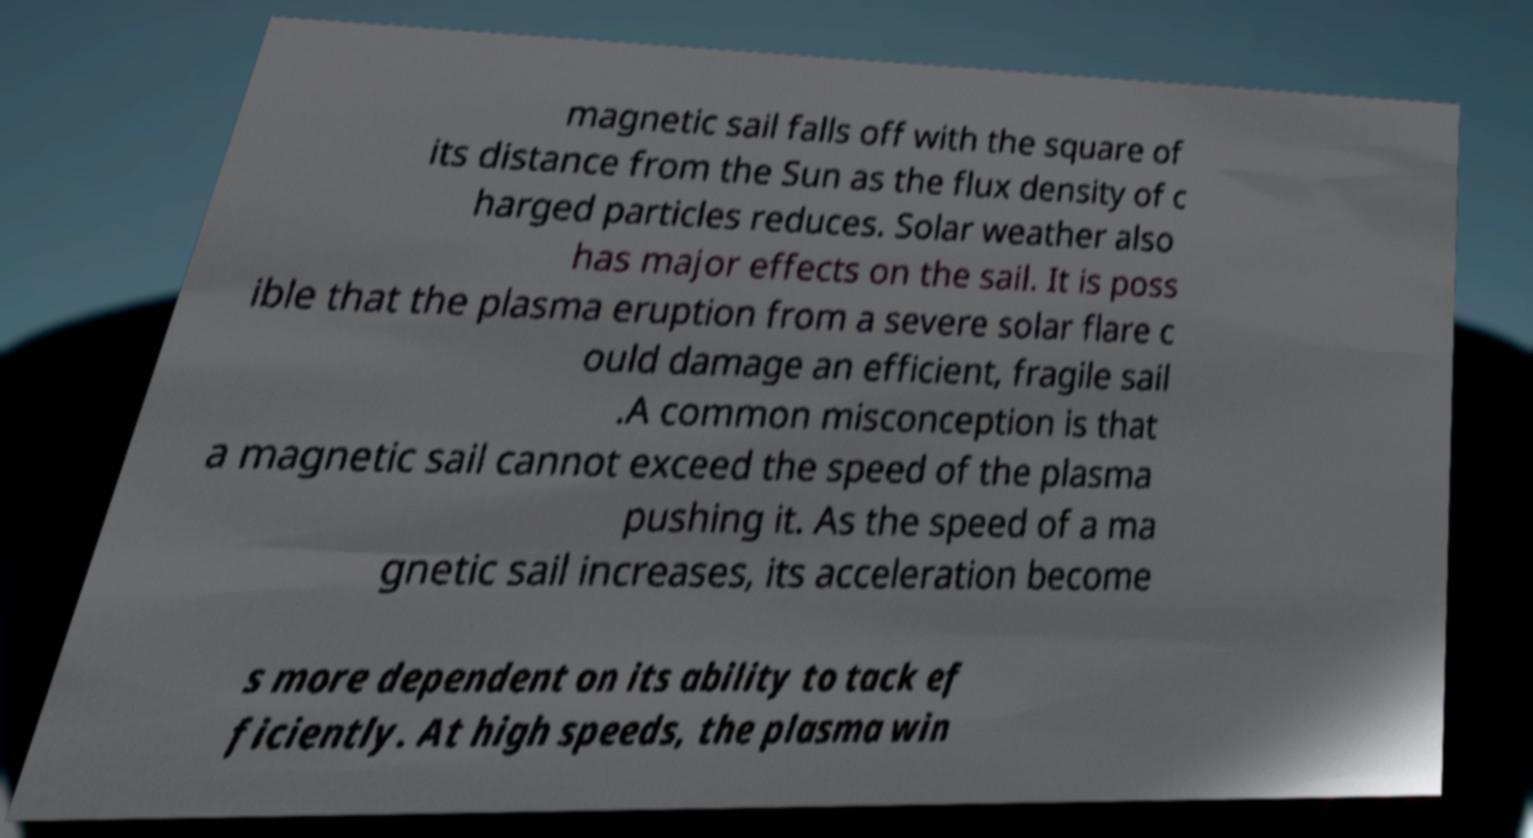Can you accurately transcribe the text from the provided image for me? magnetic sail falls off with the square of its distance from the Sun as the flux density of c harged particles reduces. Solar weather also has major effects on the sail. It is poss ible that the plasma eruption from a severe solar flare c ould damage an efficient, fragile sail .A common misconception is that a magnetic sail cannot exceed the speed of the plasma pushing it. As the speed of a ma gnetic sail increases, its acceleration become s more dependent on its ability to tack ef ficiently. At high speeds, the plasma win 